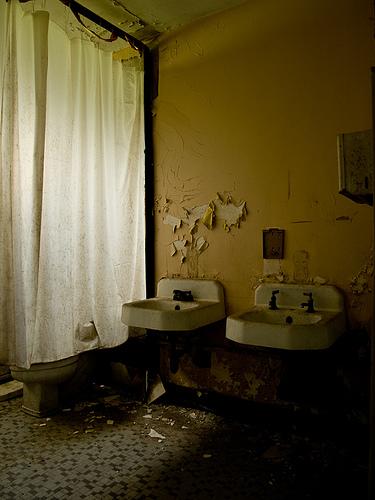What is the state of this room?
Short answer required. Bad. How many sinks are there?
Concise answer only. 2. What are the large white objects on the wall?
Keep it brief. Sinks. What room is this?
Answer briefly. Bathroom. Are the curtains more than one color?
Give a very brief answer. No. 